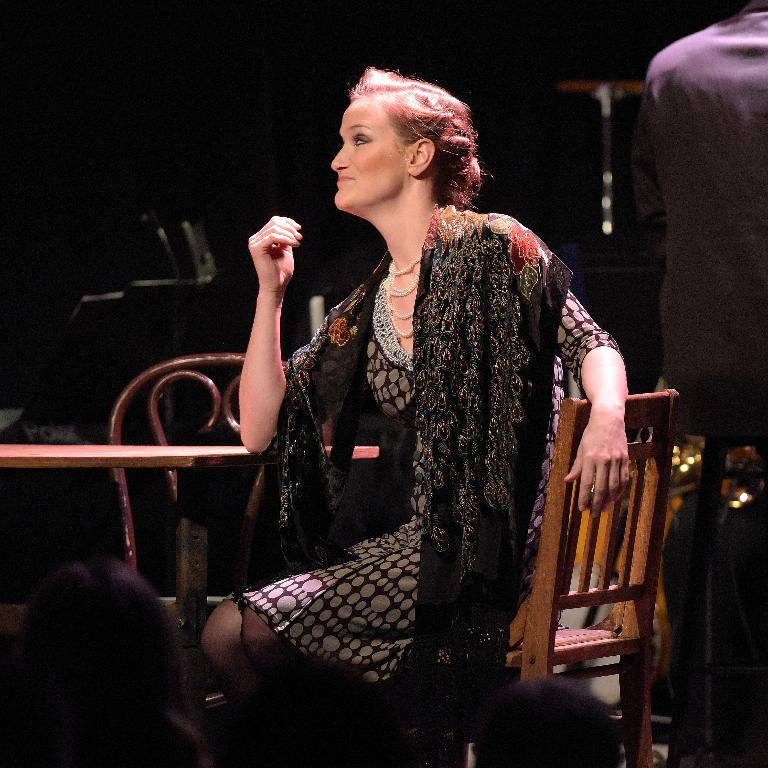What is the lady in the image doing? The lady is sitting on a chair in the image. What object is located in the center of the image? There is a table in the center of the image. Can you describe the people's heads visible at the bottom of the image? People's heads are visible at the bottom of the image, but their bodies are not shown. What year is depicted in the image? The image does not depict a specific year; it is a still image of a lady sitting on a chair, a table, and people's heads. Is there a judge present in the image? There is no judge present in the image. 